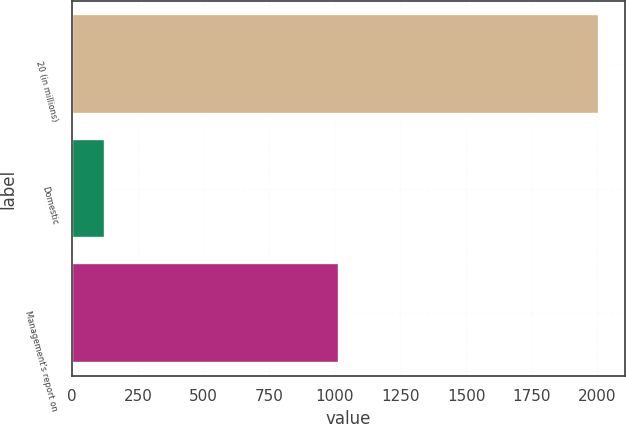<chart> <loc_0><loc_0><loc_500><loc_500><bar_chart><fcel>20 (in millions)<fcel>Domestic<fcel>Management's report on<nl><fcel>2005<fcel>126<fcel>1017<nl></chart> 